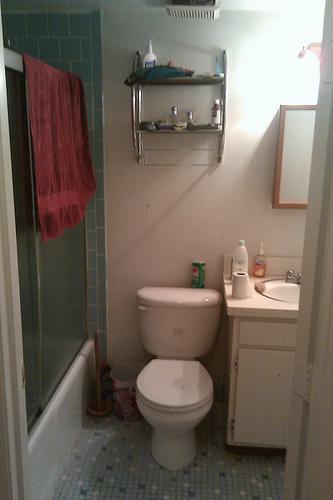Question: how the image looks?
Choices:
A. Blurry.
B. Clear.
C. Neat.
D. Overexposed.
Answer with the letter. Answer: C 